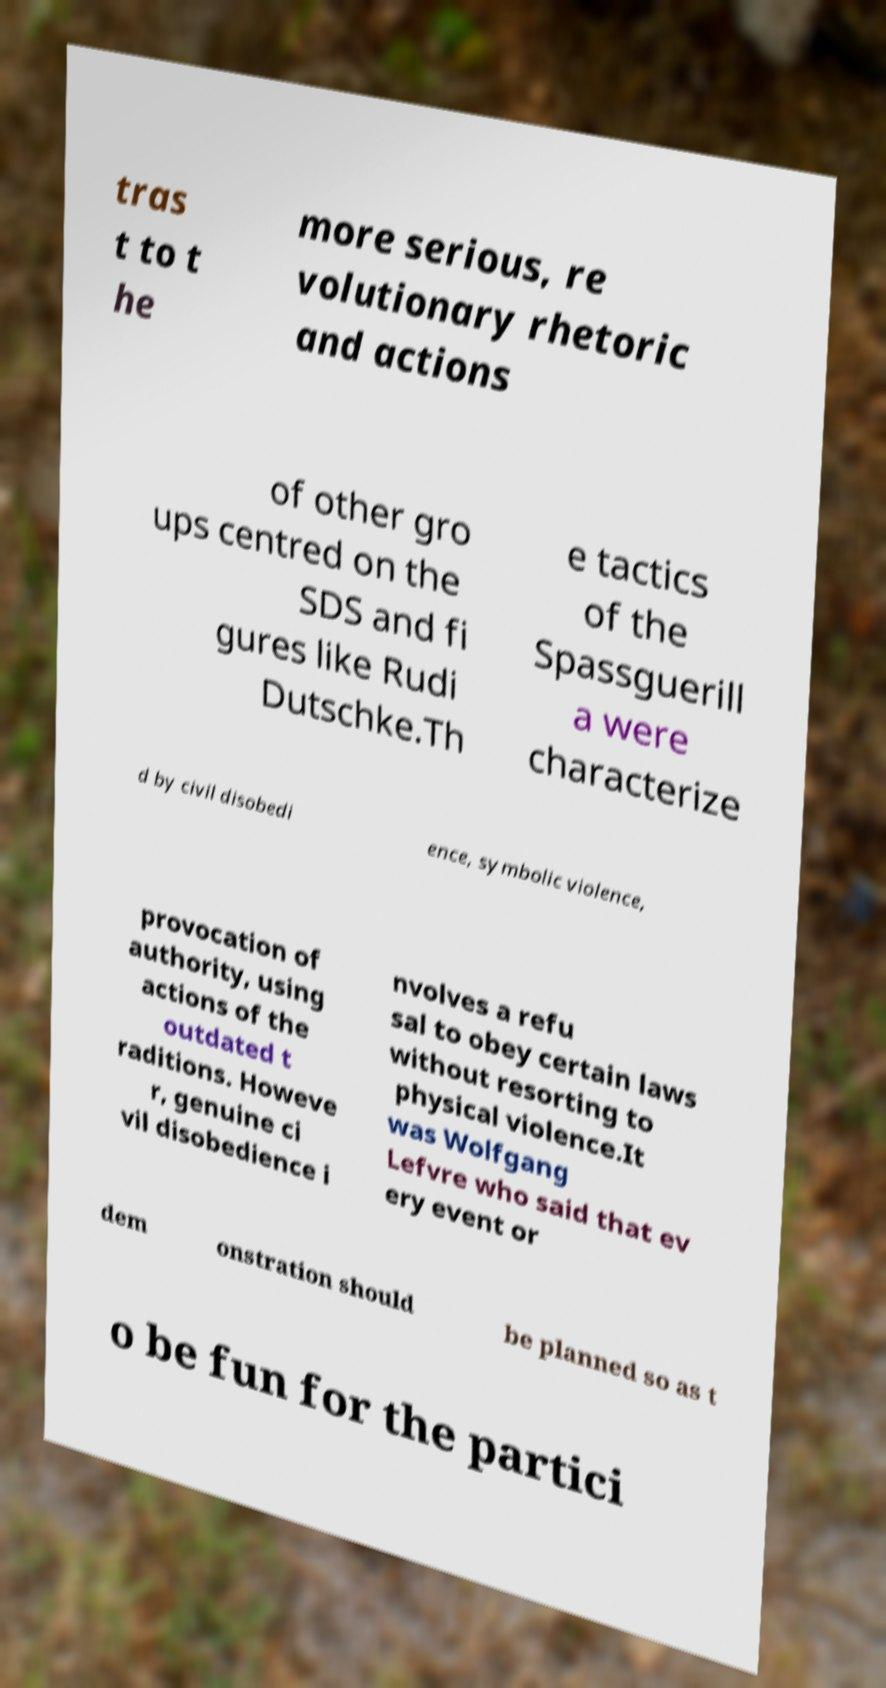Could you extract and type out the text from this image? tras t to t he more serious, re volutionary rhetoric and actions of other gro ups centred on the SDS and fi gures like Rudi Dutschke.Th e tactics of the Spassguerill a were characterize d by civil disobedi ence, symbolic violence, provocation of authority, using actions of the outdated t raditions. Howeve r, genuine ci vil disobedience i nvolves a refu sal to obey certain laws without resorting to physical violence.It was Wolfgang Lefvre who said that ev ery event or dem onstration should be planned so as t o be fun for the partici 